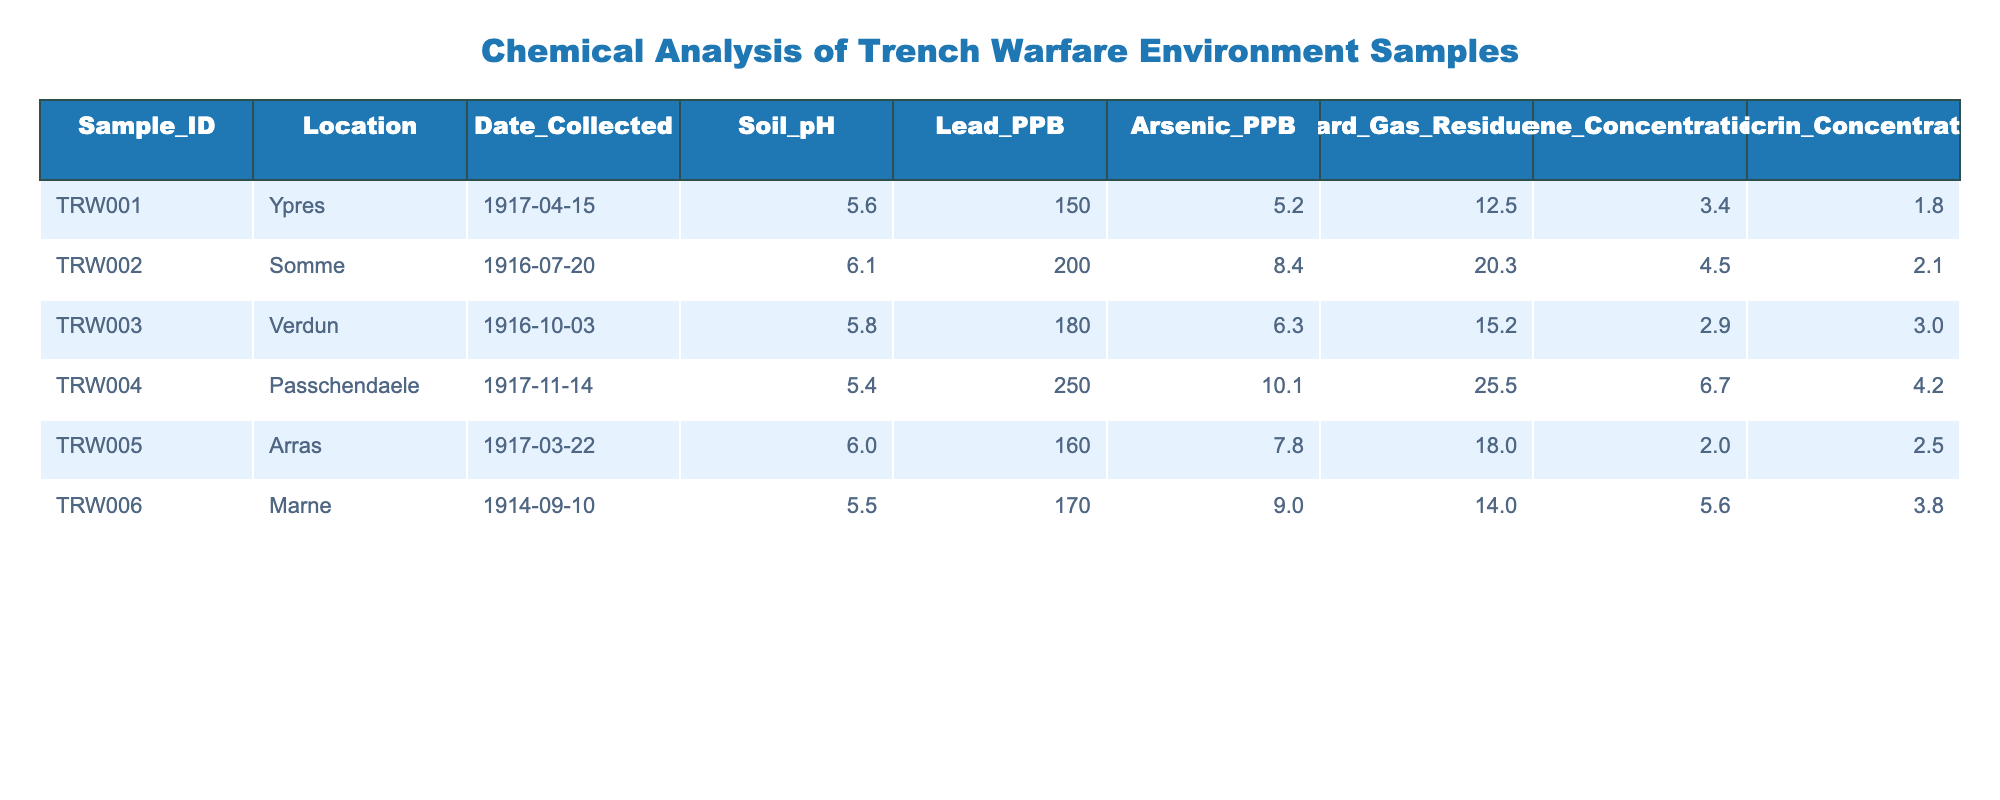What is the soil pH of the sample collected at Ypres? The table indicates that the soil pH for the sample collected at Ypres (TRW001) is 5.6.
Answer: 5.6 What is the concentration of Mustard Gas Residue in the sample from Passchendaele? The table shows that the concentration of Mustard Gas Residue for the sample from Passchendaele (TRW004) is 25.5 PPB.
Answer: 25.5 PPB How many samples have a lead concentration greater than 200 PPB? Referring to the Lead PPB column, there is only one sample, TRW004 from Passchendaele, which has a lead concentration of 250 PPB.
Answer: 1 What is the average concentration of Chloropicrin across all samples? To find the average Chloropicrin concentration, sum all the values: 1.8 + 2.1 + 3.0 + 4.2 + 2.5 + 3.8 = 17.4. Then, divide by the number of samples (6): 17.4 / 6 = 2.9.
Answer: 2.9 PPB Is there an Arsenic concentration of 10 PPB or higher in any of the samples? Looking at the Arsenic PPB column, the highest concentration is 10.1 PPB in the sample from Passchendaele (TRW004), which confirms the presence of at least one sample with Arsenic levels equal or greater than 10 PPB.
Answer: Yes Which location has the highest overall chemical concentration based on the sum of all chemical residues? To find the location with the highest overall chemical concentration, we need to sum the residues for each location. For Passchendaele, the sum is 250 + 10.1 + 25.5 + 6.7 + 4.2 = 296.5. Continuing this for each location shows Passchendaele has the highest overall concentration.
Answer: Passchendaele What is the difference in lead concentration between the sample from the Somme and the sample from Verdun? The lead concentration for the Somme is 200 PPB and for Verdun it is 180 PPB. The difference can be calculated as 200 - 180 = 20 PPB.
Answer: 20 PPB How many samples were collected before the year 1916? By examining the Date Collected column, only the sample from Marne (1914-09-10) was collected before 1916, making the total count of samples before 1916 equal to one.
Answer: 1 